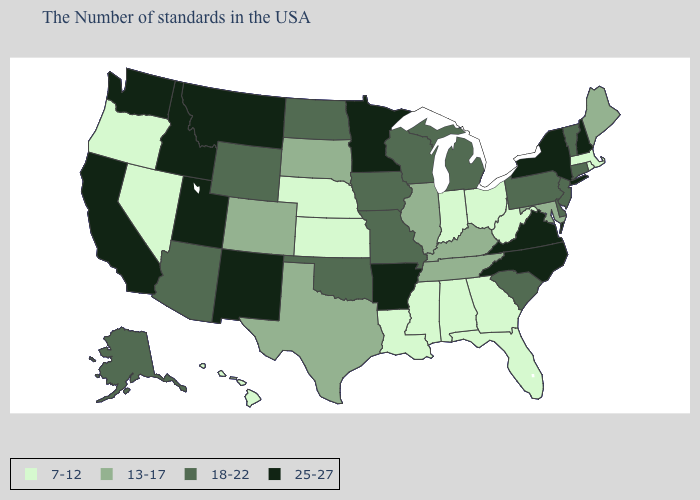Among the states that border Illinois , which have the lowest value?
Give a very brief answer. Indiana. Name the states that have a value in the range 25-27?
Short answer required. New Hampshire, New York, Virginia, North Carolina, Arkansas, Minnesota, New Mexico, Utah, Montana, Idaho, California, Washington. Among the states that border Virginia , does Maryland have the lowest value?
Write a very short answer. No. Is the legend a continuous bar?
Be succinct. No. Does Vermont have the lowest value in the Northeast?
Write a very short answer. No. Name the states that have a value in the range 13-17?
Write a very short answer. Maine, Maryland, Kentucky, Tennessee, Illinois, Texas, South Dakota, Colorado. What is the value of Vermont?
Quick response, please. 18-22. Among the states that border Tennessee , which have the highest value?
Keep it brief. Virginia, North Carolina, Arkansas. Does the map have missing data?
Quick response, please. No. Name the states that have a value in the range 18-22?
Write a very short answer. Vermont, Connecticut, New Jersey, Delaware, Pennsylvania, South Carolina, Michigan, Wisconsin, Missouri, Iowa, Oklahoma, North Dakota, Wyoming, Arizona, Alaska. Is the legend a continuous bar?
Write a very short answer. No. Does Wisconsin have the highest value in the USA?
Short answer required. No. Does the map have missing data?
Give a very brief answer. No. Does Minnesota have the highest value in the MidWest?
Keep it brief. Yes. Among the states that border Vermont , does New York have the highest value?
Be succinct. Yes. 